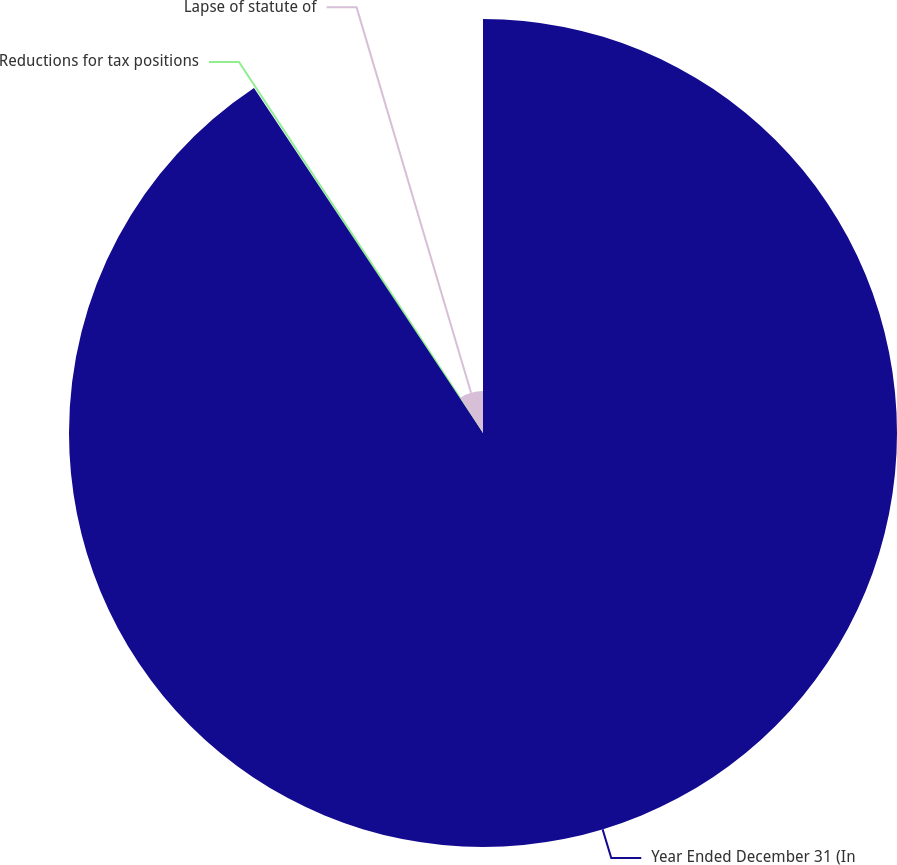<chart> <loc_0><loc_0><loc_500><loc_500><pie_chart><fcel>Year Ended December 31 (In<fcel>Reductions for tax positions<fcel>Lapse of statute of<nl><fcel>90.68%<fcel>0.14%<fcel>9.19%<nl></chart> 